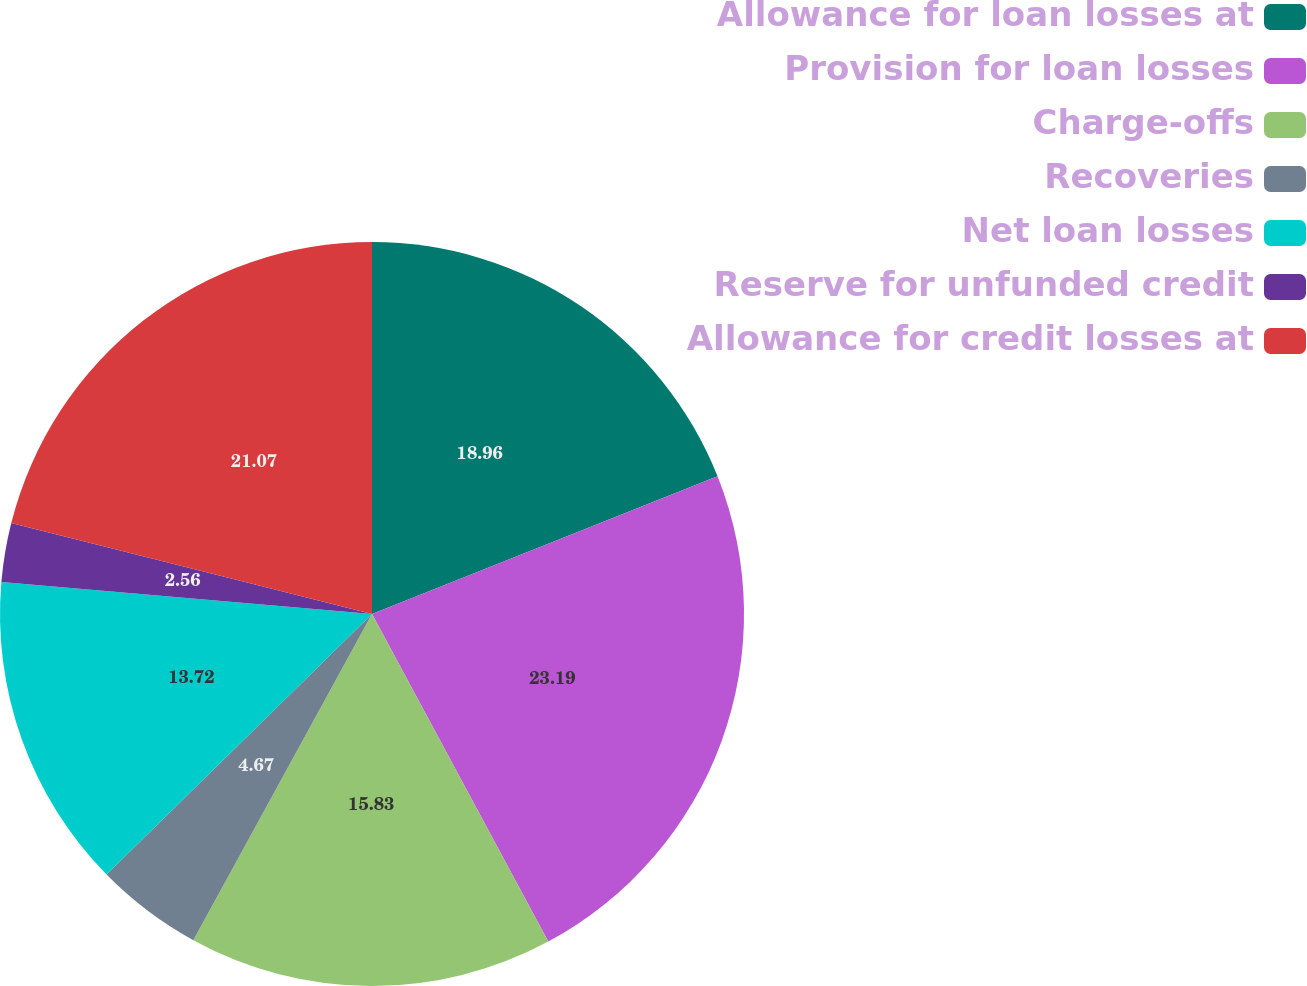<chart> <loc_0><loc_0><loc_500><loc_500><pie_chart><fcel>Allowance for loan losses at<fcel>Provision for loan losses<fcel>Charge-offs<fcel>Recoveries<fcel>Net loan losses<fcel>Reserve for unfunded credit<fcel>Allowance for credit losses at<nl><fcel>18.96%<fcel>23.18%<fcel>15.83%<fcel>4.67%<fcel>13.72%<fcel>2.56%<fcel>21.07%<nl></chart> 